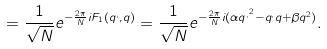Convert formula to latex. <formula><loc_0><loc_0><loc_500><loc_500>= \frac { 1 } { \sqrt { N } } e ^ { - \frac { 2 \pi } { N } i F _ { 1 } ( q ^ { , } , q ) } = \frac { 1 } { \sqrt { N } } e ^ { - \frac { 2 \pi } { N } i ( \alpha q ^ { , ^ { 2 } } - q ^ { , } q + \beta q ^ { 2 } ) } .</formula> 